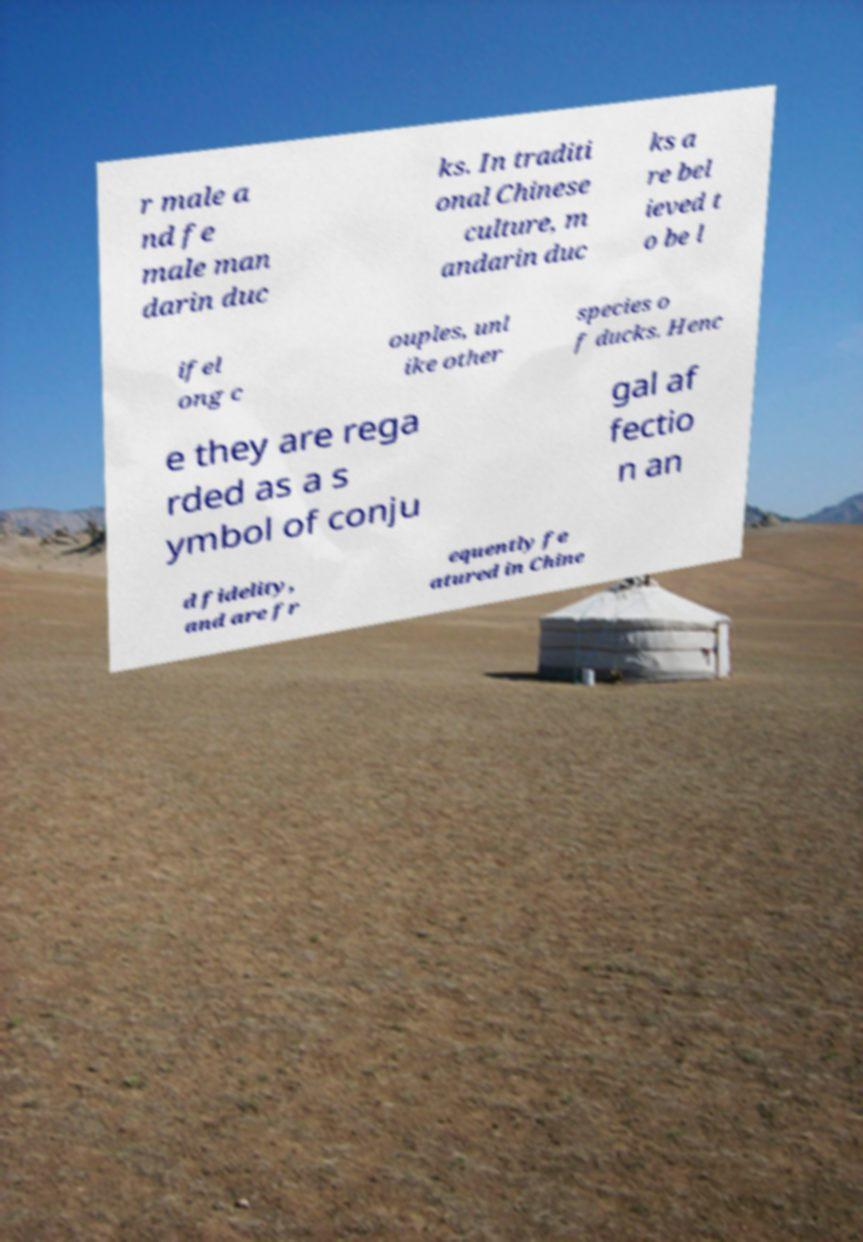Could you assist in decoding the text presented in this image and type it out clearly? r male a nd fe male man darin duc ks. In traditi onal Chinese culture, m andarin duc ks a re bel ieved t o be l ifel ong c ouples, unl ike other species o f ducks. Henc e they are rega rded as a s ymbol of conju gal af fectio n an d fidelity, and are fr equently fe atured in Chine 